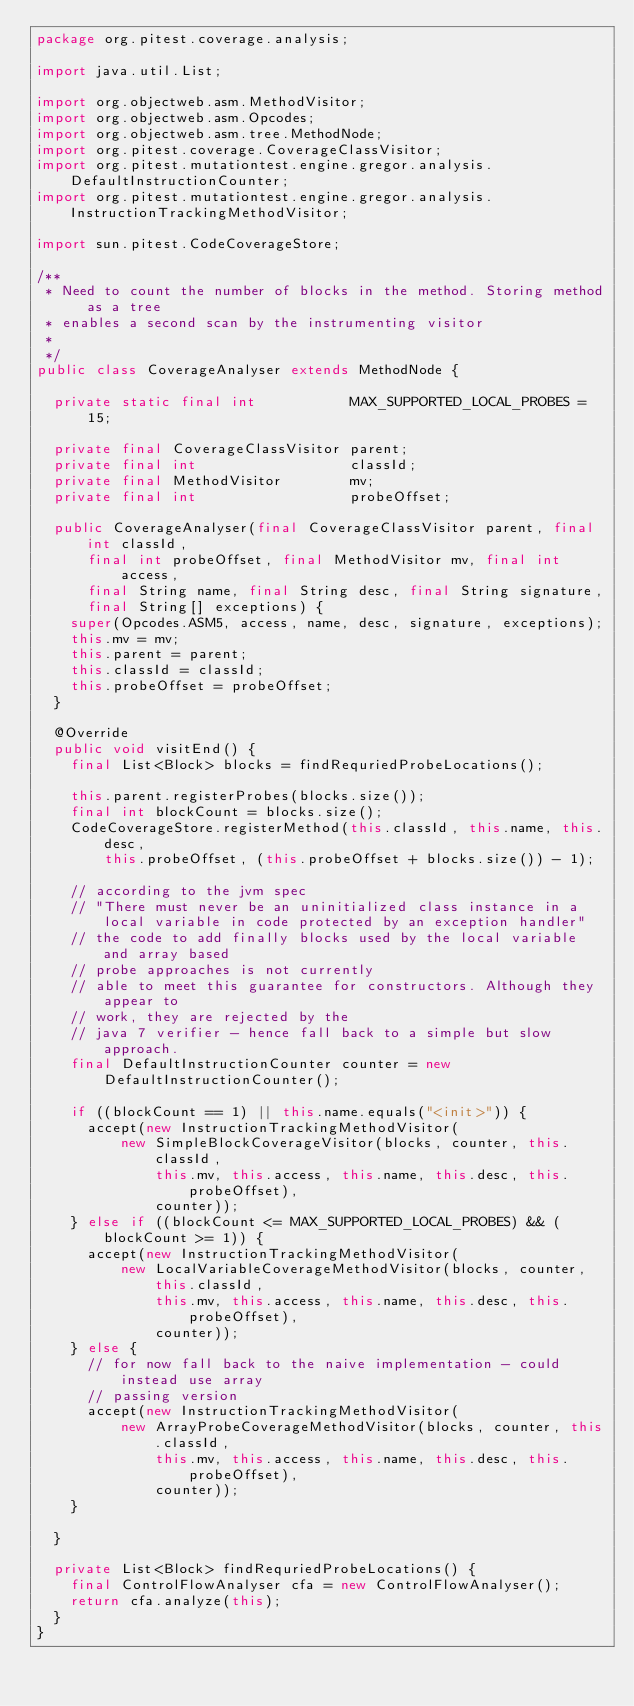Convert code to text. <code><loc_0><loc_0><loc_500><loc_500><_Java_>package org.pitest.coverage.analysis;

import java.util.List;

import org.objectweb.asm.MethodVisitor;
import org.objectweb.asm.Opcodes;
import org.objectweb.asm.tree.MethodNode;
import org.pitest.coverage.CoverageClassVisitor;
import org.pitest.mutationtest.engine.gregor.analysis.DefaultInstructionCounter;
import org.pitest.mutationtest.engine.gregor.analysis.InstructionTrackingMethodVisitor;

import sun.pitest.CodeCoverageStore;

/**
 * Need to count the number of blocks in the method. Storing method as a tree
 * enables a second scan by the instrumenting visitor
 *
 */
public class CoverageAnalyser extends MethodNode {

  private static final int           MAX_SUPPORTED_LOCAL_PROBES = 15;

  private final CoverageClassVisitor parent;
  private final int                  classId;
  private final MethodVisitor        mv;
  private final int                  probeOffset;

  public CoverageAnalyser(final CoverageClassVisitor parent, final int classId,
      final int probeOffset, final MethodVisitor mv, final int access,
      final String name, final String desc, final String signature,
      final String[] exceptions) {
    super(Opcodes.ASM5, access, name, desc, signature, exceptions);
    this.mv = mv;
    this.parent = parent;
    this.classId = classId;
    this.probeOffset = probeOffset;
  }

  @Override
  public void visitEnd() {
    final List<Block> blocks = findRequriedProbeLocations();

    this.parent.registerProbes(blocks.size());
    final int blockCount = blocks.size();
    CodeCoverageStore.registerMethod(this.classId, this.name, this.desc,
        this.probeOffset, (this.probeOffset + blocks.size()) - 1);

    // according to the jvm spec
    // "There must never be an uninitialized class instance in a local variable in code protected by an exception handler"
    // the code to add finally blocks used by the local variable and array based
    // probe approaches is not currently
    // able to meet this guarantee for constructors. Although they appear to
    // work, they are rejected by the
    // java 7 verifier - hence fall back to a simple but slow approach.
    final DefaultInstructionCounter counter = new DefaultInstructionCounter();

    if ((blockCount == 1) || this.name.equals("<init>")) {
      accept(new InstructionTrackingMethodVisitor(
          new SimpleBlockCoverageVisitor(blocks, counter, this.classId,
              this.mv, this.access, this.name, this.desc, this.probeOffset),
              counter));
    } else if ((blockCount <= MAX_SUPPORTED_LOCAL_PROBES) && (blockCount >= 1)) {
      accept(new InstructionTrackingMethodVisitor(
          new LocalVariableCoverageMethodVisitor(blocks, counter, this.classId,
              this.mv, this.access, this.name, this.desc, this.probeOffset),
              counter));
    } else {
      // for now fall back to the naive implementation - could instead use array
      // passing version
      accept(new InstructionTrackingMethodVisitor(
          new ArrayProbeCoverageMethodVisitor(blocks, counter, this.classId,
              this.mv, this.access, this.name, this.desc, this.probeOffset),
              counter));
    }

  }

  private List<Block> findRequriedProbeLocations() {
    final ControlFlowAnalyser cfa = new ControlFlowAnalyser();
    return cfa.analyze(this);
  }
}
</code> 